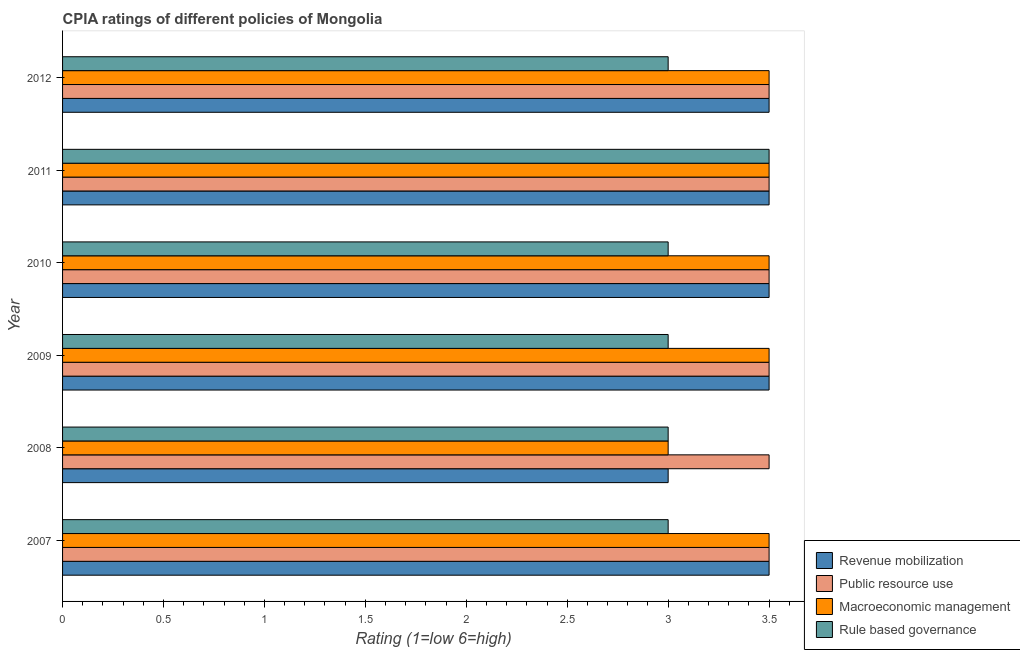How many different coloured bars are there?
Your answer should be compact. 4. How many groups of bars are there?
Keep it short and to the point. 6. Are the number of bars per tick equal to the number of legend labels?
Offer a very short reply. Yes. In how many cases, is the number of bars for a given year not equal to the number of legend labels?
Provide a short and direct response. 0. Across all years, what is the maximum cpia rating of rule based governance?
Provide a short and direct response. 3.5. Across all years, what is the minimum cpia rating of public resource use?
Make the answer very short. 3.5. What is the total cpia rating of revenue mobilization in the graph?
Your answer should be compact. 20.5. What is the difference between the cpia rating of rule based governance in 2007 and that in 2009?
Ensure brevity in your answer.  0. What is the average cpia rating of macroeconomic management per year?
Provide a succinct answer. 3.42. In the year 2012, what is the difference between the cpia rating of revenue mobilization and cpia rating of public resource use?
Offer a terse response. 0. In how many years, is the cpia rating of public resource use greater than 2.7 ?
Keep it short and to the point. 6. What is the ratio of the cpia rating of rule based governance in 2007 to that in 2011?
Your response must be concise. 0.86. Is the cpia rating of public resource use in 2008 less than that in 2010?
Provide a short and direct response. No. What is the difference between the highest and the lowest cpia rating of revenue mobilization?
Ensure brevity in your answer.  0.5. In how many years, is the cpia rating of public resource use greater than the average cpia rating of public resource use taken over all years?
Ensure brevity in your answer.  0. Is the sum of the cpia rating of macroeconomic management in 2009 and 2011 greater than the maximum cpia rating of public resource use across all years?
Offer a terse response. Yes. What does the 1st bar from the top in 2008 represents?
Your answer should be very brief. Rule based governance. What does the 2nd bar from the bottom in 2008 represents?
Your answer should be compact. Public resource use. How many years are there in the graph?
Provide a short and direct response. 6. What is the difference between two consecutive major ticks on the X-axis?
Keep it short and to the point. 0.5. Does the graph contain any zero values?
Your response must be concise. No. Does the graph contain grids?
Your answer should be very brief. No. Where does the legend appear in the graph?
Give a very brief answer. Bottom right. How are the legend labels stacked?
Offer a very short reply. Vertical. What is the title of the graph?
Provide a short and direct response. CPIA ratings of different policies of Mongolia. Does "Taxes on exports" appear as one of the legend labels in the graph?
Your answer should be compact. No. What is the label or title of the X-axis?
Offer a terse response. Rating (1=low 6=high). What is the Rating (1=low 6=high) of Macroeconomic management in 2007?
Ensure brevity in your answer.  3.5. What is the Rating (1=low 6=high) of Rule based governance in 2007?
Ensure brevity in your answer.  3. What is the Rating (1=low 6=high) of Public resource use in 2008?
Offer a terse response. 3.5. What is the Rating (1=low 6=high) in Public resource use in 2010?
Provide a short and direct response. 3.5. What is the Rating (1=low 6=high) of Public resource use in 2011?
Your answer should be compact. 3.5. What is the Rating (1=low 6=high) of Macroeconomic management in 2011?
Your answer should be very brief. 3.5. What is the Rating (1=low 6=high) of Rule based governance in 2011?
Provide a succinct answer. 3.5. What is the Rating (1=low 6=high) of Revenue mobilization in 2012?
Your answer should be very brief. 3.5. What is the Rating (1=low 6=high) in Macroeconomic management in 2012?
Give a very brief answer. 3.5. Across all years, what is the maximum Rating (1=low 6=high) of Macroeconomic management?
Ensure brevity in your answer.  3.5. Across all years, what is the minimum Rating (1=low 6=high) in Rule based governance?
Offer a very short reply. 3. What is the total Rating (1=low 6=high) in Public resource use in the graph?
Offer a very short reply. 21. What is the total Rating (1=low 6=high) in Macroeconomic management in the graph?
Your answer should be very brief. 20.5. What is the total Rating (1=low 6=high) in Rule based governance in the graph?
Provide a succinct answer. 18.5. What is the difference between the Rating (1=low 6=high) in Public resource use in 2007 and that in 2008?
Make the answer very short. 0. What is the difference between the Rating (1=low 6=high) in Revenue mobilization in 2007 and that in 2009?
Provide a succinct answer. 0. What is the difference between the Rating (1=low 6=high) in Macroeconomic management in 2007 and that in 2009?
Your response must be concise. 0. What is the difference between the Rating (1=low 6=high) of Revenue mobilization in 2007 and that in 2010?
Make the answer very short. 0. What is the difference between the Rating (1=low 6=high) of Public resource use in 2007 and that in 2010?
Make the answer very short. 0. What is the difference between the Rating (1=low 6=high) of Macroeconomic management in 2007 and that in 2010?
Keep it short and to the point. 0. What is the difference between the Rating (1=low 6=high) in Public resource use in 2007 and that in 2012?
Your answer should be compact. 0. What is the difference between the Rating (1=low 6=high) of Rule based governance in 2007 and that in 2012?
Your response must be concise. 0. What is the difference between the Rating (1=low 6=high) in Revenue mobilization in 2008 and that in 2009?
Provide a succinct answer. -0.5. What is the difference between the Rating (1=low 6=high) in Rule based governance in 2008 and that in 2009?
Ensure brevity in your answer.  0. What is the difference between the Rating (1=low 6=high) in Macroeconomic management in 2008 and that in 2010?
Ensure brevity in your answer.  -0.5. What is the difference between the Rating (1=low 6=high) in Revenue mobilization in 2008 and that in 2011?
Provide a short and direct response. -0.5. What is the difference between the Rating (1=low 6=high) of Public resource use in 2008 and that in 2011?
Your answer should be compact. 0. What is the difference between the Rating (1=low 6=high) of Revenue mobilization in 2008 and that in 2012?
Ensure brevity in your answer.  -0.5. What is the difference between the Rating (1=low 6=high) in Macroeconomic management in 2008 and that in 2012?
Provide a succinct answer. -0.5. What is the difference between the Rating (1=low 6=high) in Public resource use in 2009 and that in 2010?
Your response must be concise. 0. What is the difference between the Rating (1=low 6=high) of Macroeconomic management in 2009 and that in 2010?
Your response must be concise. 0. What is the difference between the Rating (1=low 6=high) in Rule based governance in 2009 and that in 2010?
Provide a short and direct response. 0. What is the difference between the Rating (1=low 6=high) of Public resource use in 2009 and that in 2011?
Give a very brief answer. 0. What is the difference between the Rating (1=low 6=high) of Macroeconomic management in 2009 and that in 2011?
Your response must be concise. 0. What is the difference between the Rating (1=low 6=high) of Macroeconomic management in 2010 and that in 2011?
Your response must be concise. 0. What is the difference between the Rating (1=low 6=high) of Revenue mobilization in 2010 and that in 2012?
Give a very brief answer. 0. What is the difference between the Rating (1=low 6=high) of Public resource use in 2010 and that in 2012?
Your response must be concise. 0. What is the difference between the Rating (1=low 6=high) of Public resource use in 2011 and that in 2012?
Provide a short and direct response. 0. What is the difference between the Rating (1=low 6=high) of Macroeconomic management in 2011 and that in 2012?
Make the answer very short. 0. What is the difference between the Rating (1=low 6=high) in Revenue mobilization in 2007 and the Rating (1=low 6=high) in Macroeconomic management in 2008?
Make the answer very short. 0.5. What is the difference between the Rating (1=low 6=high) in Public resource use in 2007 and the Rating (1=low 6=high) in Rule based governance in 2008?
Offer a terse response. 0.5. What is the difference between the Rating (1=low 6=high) in Revenue mobilization in 2007 and the Rating (1=low 6=high) in Public resource use in 2009?
Keep it short and to the point. 0. What is the difference between the Rating (1=low 6=high) of Public resource use in 2007 and the Rating (1=low 6=high) of Macroeconomic management in 2009?
Provide a succinct answer. 0. What is the difference between the Rating (1=low 6=high) of Public resource use in 2007 and the Rating (1=low 6=high) of Rule based governance in 2009?
Your answer should be compact. 0.5. What is the difference between the Rating (1=low 6=high) of Revenue mobilization in 2007 and the Rating (1=low 6=high) of Rule based governance in 2010?
Provide a short and direct response. 0.5. What is the difference between the Rating (1=low 6=high) of Macroeconomic management in 2007 and the Rating (1=low 6=high) of Rule based governance in 2010?
Your answer should be very brief. 0.5. What is the difference between the Rating (1=low 6=high) in Revenue mobilization in 2007 and the Rating (1=low 6=high) in Macroeconomic management in 2011?
Offer a terse response. 0. What is the difference between the Rating (1=low 6=high) in Public resource use in 2007 and the Rating (1=low 6=high) in Macroeconomic management in 2011?
Offer a very short reply. 0. What is the difference between the Rating (1=low 6=high) of Macroeconomic management in 2007 and the Rating (1=low 6=high) of Rule based governance in 2011?
Provide a short and direct response. 0. What is the difference between the Rating (1=low 6=high) of Revenue mobilization in 2007 and the Rating (1=low 6=high) of Public resource use in 2012?
Your answer should be compact. 0. What is the difference between the Rating (1=low 6=high) in Revenue mobilization in 2007 and the Rating (1=low 6=high) in Macroeconomic management in 2012?
Provide a succinct answer. 0. What is the difference between the Rating (1=low 6=high) in Revenue mobilization in 2008 and the Rating (1=low 6=high) in Public resource use in 2009?
Provide a short and direct response. -0.5. What is the difference between the Rating (1=low 6=high) in Revenue mobilization in 2008 and the Rating (1=low 6=high) in Macroeconomic management in 2009?
Your answer should be very brief. -0.5. What is the difference between the Rating (1=low 6=high) of Public resource use in 2008 and the Rating (1=low 6=high) of Macroeconomic management in 2009?
Offer a terse response. 0. What is the difference between the Rating (1=low 6=high) of Macroeconomic management in 2008 and the Rating (1=low 6=high) of Rule based governance in 2009?
Offer a very short reply. 0. What is the difference between the Rating (1=low 6=high) of Revenue mobilization in 2008 and the Rating (1=low 6=high) of Rule based governance in 2010?
Your answer should be compact. 0. What is the difference between the Rating (1=low 6=high) of Revenue mobilization in 2008 and the Rating (1=low 6=high) of Public resource use in 2011?
Provide a succinct answer. -0.5. What is the difference between the Rating (1=low 6=high) of Revenue mobilization in 2008 and the Rating (1=low 6=high) of Macroeconomic management in 2011?
Your response must be concise. -0.5. What is the difference between the Rating (1=low 6=high) in Revenue mobilization in 2008 and the Rating (1=low 6=high) in Rule based governance in 2011?
Provide a short and direct response. -0.5. What is the difference between the Rating (1=low 6=high) in Macroeconomic management in 2008 and the Rating (1=low 6=high) in Rule based governance in 2011?
Offer a very short reply. -0.5. What is the difference between the Rating (1=low 6=high) of Revenue mobilization in 2008 and the Rating (1=low 6=high) of Rule based governance in 2012?
Give a very brief answer. 0. What is the difference between the Rating (1=low 6=high) of Public resource use in 2008 and the Rating (1=low 6=high) of Rule based governance in 2012?
Your answer should be very brief. 0.5. What is the difference between the Rating (1=low 6=high) in Macroeconomic management in 2008 and the Rating (1=low 6=high) in Rule based governance in 2012?
Your answer should be very brief. 0. What is the difference between the Rating (1=low 6=high) in Revenue mobilization in 2009 and the Rating (1=low 6=high) in Rule based governance in 2010?
Provide a short and direct response. 0.5. What is the difference between the Rating (1=low 6=high) in Public resource use in 2009 and the Rating (1=low 6=high) in Rule based governance in 2011?
Offer a terse response. 0. What is the difference between the Rating (1=low 6=high) in Public resource use in 2009 and the Rating (1=low 6=high) in Macroeconomic management in 2012?
Your response must be concise. 0. What is the difference between the Rating (1=low 6=high) in Public resource use in 2009 and the Rating (1=low 6=high) in Rule based governance in 2012?
Ensure brevity in your answer.  0.5. What is the difference between the Rating (1=low 6=high) in Revenue mobilization in 2010 and the Rating (1=low 6=high) in Public resource use in 2011?
Your response must be concise. 0. What is the difference between the Rating (1=low 6=high) of Revenue mobilization in 2010 and the Rating (1=low 6=high) of Macroeconomic management in 2011?
Ensure brevity in your answer.  0. What is the difference between the Rating (1=low 6=high) in Revenue mobilization in 2010 and the Rating (1=low 6=high) in Rule based governance in 2012?
Your response must be concise. 0.5. What is the difference between the Rating (1=low 6=high) in Public resource use in 2010 and the Rating (1=low 6=high) in Macroeconomic management in 2012?
Your answer should be very brief. 0. What is the difference between the Rating (1=low 6=high) in Macroeconomic management in 2010 and the Rating (1=low 6=high) in Rule based governance in 2012?
Your answer should be compact. 0.5. What is the difference between the Rating (1=low 6=high) of Revenue mobilization in 2011 and the Rating (1=low 6=high) of Public resource use in 2012?
Offer a very short reply. 0. What is the difference between the Rating (1=low 6=high) in Public resource use in 2011 and the Rating (1=low 6=high) in Macroeconomic management in 2012?
Keep it short and to the point. 0. What is the difference between the Rating (1=low 6=high) in Public resource use in 2011 and the Rating (1=low 6=high) in Rule based governance in 2012?
Your response must be concise. 0.5. What is the average Rating (1=low 6=high) of Revenue mobilization per year?
Offer a terse response. 3.42. What is the average Rating (1=low 6=high) in Macroeconomic management per year?
Make the answer very short. 3.42. What is the average Rating (1=low 6=high) of Rule based governance per year?
Offer a terse response. 3.08. In the year 2007, what is the difference between the Rating (1=low 6=high) in Revenue mobilization and Rating (1=low 6=high) in Rule based governance?
Your answer should be compact. 0.5. In the year 2007, what is the difference between the Rating (1=low 6=high) in Public resource use and Rating (1=low 6=high) in Macroeconomic management?
Offer a terse response. 0. In the year 2007, what is the difference between the Rating (1=low 6=high) of Public resource use and Rating (1=low 6=high) of Rule based governance?
Provide a succinct answer. 0.5. In the year 2009, what is the difference between the Rating (1=low 6=high) in Revenue mobilization and Rating (1=low 6=high) in Macroeconomic management?
Give a very brief answer. 0. In the year 2009, what is the difference between the Rating (1=low 6=high) of Public resource use and Rating (1=low 6=high) of Macroeconomic management?
Keep it short and to the point. 0. In the year 2010, what is the difference between the Rating (1=low 6=high) in Revenue mobilization and Rating (1=low 6=high) in Public resource use?
Ensure brevity in your answer.  0. In the year 2010, what is the difference between the Rating (1=low 6=high) in Revenue mobilization and Rating (1=low 6=high) in Macroeconomic management?
Offer a very short reply. 0. In the year 2010, what is the difference between the Rating (1=low 6=high) of Public resource use and Rating (1=low 6=high) of Macroeconomic management?
Your answer should be very brief. 0. In the year 2010, what is the difference between the Rating (1=low 6=high) of Public resource use and Rating (1=low 6=high) of Rule based governance?
Ensure brevity in your answer.  0.5. In the year 2010, what is the difference between the Rating (1=low 6=high) of Macroeconomic management and Rating (1=low 6=high) of Rule based governance?
Your answer should be compact. 0.5. In the year 2011, what is the difference between the Rating (1=low 6=high) of Revenue mobilization and Rating (1=low 6=high) of Public resource use?
Your response must be concise. 0. In the year 2011, what is the difference between the Rating (1=low 6=high) in Revenue mobilization and Rating (1=low 6=high) in Rule based governance?
Your response must be concise. 0. In the year 2011, what is the difference between the Rating (1=low 6=high) in Public resource use and Rating (1=low 6=high) in Macroeconomic management?
Ensure brevity in your answer.  0. In the year 2012, what is the difference between the Rating (1=low 6=high) of Revenue mobilization and Rating (1=low 6=high) of Public resource use?
Offer a terse response. 0. In the year 2012, what is the difference between the Rating (1=low 6=high) of Revenue mobilization and Rating (1=low 6=high) of Macroeconomic management?
Ensure brevity in your answer.  0. In the year 2012, what is the difference between the Rating (1=low 6=high) of Revenue mobilization and Rating (1=low 6=high) of Rule based governance?
Your answer should be very brief. 0.5. What is the ratio of the Rating (1=low 6=high) in Revenue mobilization in 2007 to that in 2008?
Your answer should be compact. 1.17. What is the ratio of the Rating (1=low 6=high) of Public resource use in 2007 to that in 2008?
Your answer should be very brief. 1. What is the ratio of the Rating (1=low 6=high) in Public resource use in 2007 to that in 2010?
Provide a succinct answer. 1. What is the ratio of the Rating (1=low 6=high) of Macroeconomic management in 2007 to that in 2010?
Keep it short and to the point. 1. What is the ratio of the Rating (1=low 6=high) of Public resource use in 2007 to that in 2011?
Your response must be concise. 1. What is the ratio of the Rating (1=low 6=high) of Macroeconomic management in 2007 to that in 2011?
Your answer should be compact. 1. What is the ratio of the Rating (1=low 6=high) of Rule based governance in 2007 to that in 2011?
Give a very brief answer. 0.86. What is the ratio of the Rating (1=low 6=high) in Public resource use in 2007 to that in 2012?
Offer a terse response. 1. What is the ratio of the Rating (1=low 6=high) in Revenue mobilization in 2008 to that in 2009?
Make the answer very short. 0.86. What is the ratio of the Rating (1=low 6=high) in Public resource use in 2008 to that in 2010?
Ensure brevity in your answer.  1. What is the ratio of the Rating (1=low 6=high) of Rule based governance in 2008 to that in 2010?
Keep it short and to the point. 1. What is the ratio of the Rating (1=low 6=high) of Public resource use in 2008 to that in 2011?
Provide a short and direct response. 1. What is the ratio of the Rating (1=low 6=high) of Macroeconomic management in 2008 to that in 2011?
Offer a very short reply. 0.86. What is the ratio of the Rating (1=low 6=high) of Revenue mobilization in 2008 to that in 2012?
Give a very brief answer. 0.86. What is the ratio of the Rating (1=low 6=high) of Public resource use in 2008 to that in 2012?
Provide a succinct answer. 1. What is the ratio of the Rating (1=low 6=high) in Macroeconomic management in 2008 to that in 2012?
Keep it short and to the point. 0.86. What is the ratio of the Rating (1=low 6=high) in Revenue mobilization in 2009 to that in 2010?
Provide a short and direct response. 1. What is the ratio of the Rating (1=low 6=high) of Public resource use in 2009 to that in 2010?
Keep it short and to the point. 1. What is the ratio of the Rating (1=low 6=high) of Rule based governance in 2009 to that in 2010?
Give a very brief answer. 1. What is the ratio of the Rating (1=low 6=high) of Public resource use in 2009 to that in 2011?
Make the answer very short. 1. What is the ratio of the Rating (1=low 6=high) in Rule based governance in 2009 to that in 2011?
Offer a very short reply. 0.86. What is the ratio of the Rating (1=low 6=high) in Revenue mobilization in 2009 to that in 2012?
Your answer should be compact. 1. What is the ratio of the Rating (1=low 6=high) in Public resource use in 2009 to that in 2012?
Keep it short and to the point. 1. What is the ratio of the Rating (1=low 6=high) of Revenue mobilization in 2010 to that in 2011?
Offer a very short reply. 1. What is the ratio of the Rating (1=low 6=high) of Public resource use in 2010 to that in 2011?
Give a very brief answer. 1. What is the ratio of the Rating (1=low 6=high) in Macroeconomic management in 2010 to that in 2011?
Your answer should be very brief. 1. What is the ratio of the Rating (1=low 6=high) of Revenue mobilization in 2010 to that in 2012?
Keep it short and to the point. 1. What is the ratio of the Rating (1=low 6=high) in Macroeconomic management in 2010 to that in 2012?
Make the answer very short. 1. What is the ratio of the Rating (1=low 6=high) in Rule based governance in 2010 to that in 2012?
Give a very brief answer. 1. What is the ratio of the Rating (1=low 6=high) of Rule based governance in 2011 to that in 2012?
Your answer should be compact. 1.17. What is the difference between the highest and the second highest Rating (1=low 6=high) of Macroeconomic management?
Offer a very short reply. 0. What is the difference between the highest and the lowest Rating (1=low 6=high) in Revenue mobilization?
Provide a succinct answer. 0.5. What is the difference between the highest and the lowest Rating (1=low 6=high) in Public resource use?
Give a very brief answer. 0. 